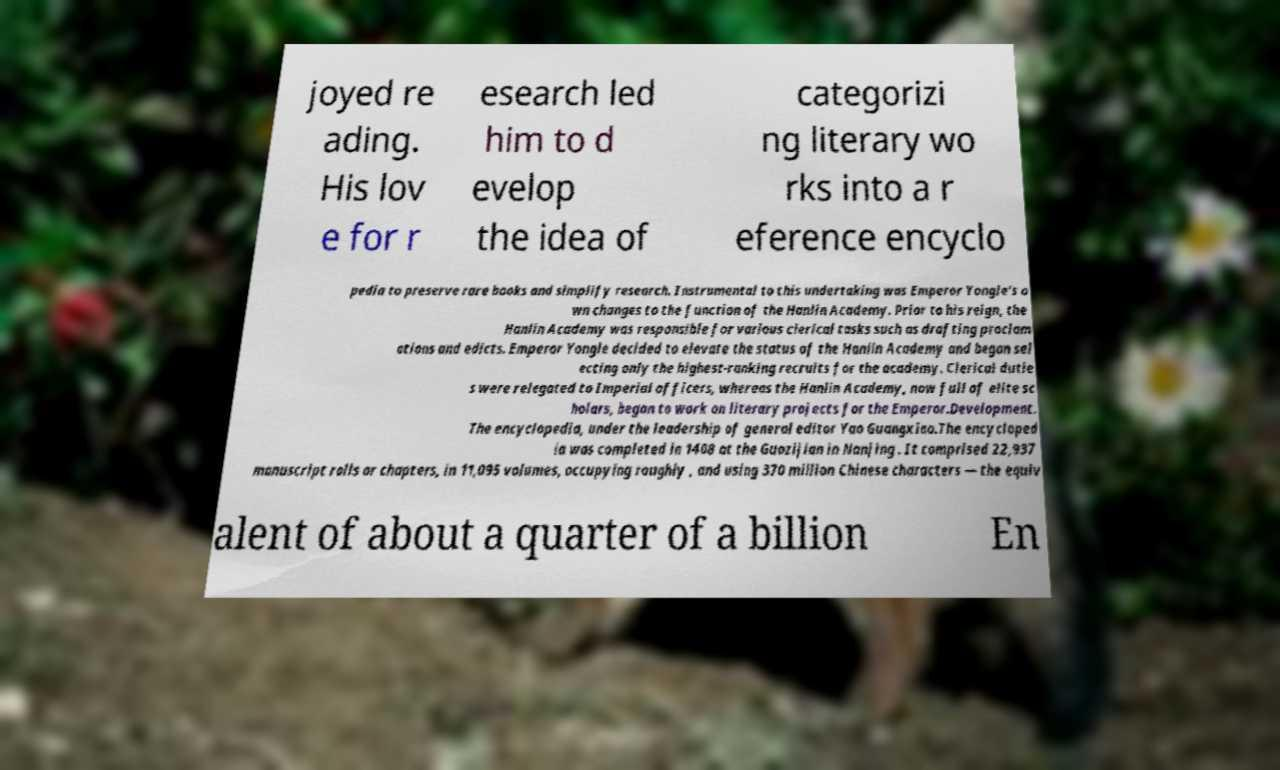Could you assist in decoding the text presented in this image and type it out clearly? joyed re ading. His lov e for r esearch led him to d evelop the idea of categorizi ng literary wo rks into a r eference encyclo pedia to preserve rare books and simplify research. Instrumental to this undertaking was Emperor Yongle’s o wn changes to the function of the Hanlin Academy. Prior to his reign, the Hanlin Academy was responsible for various clerical tasks such as drafting proclam ations and edicts. Emperor Yongle decided to elevate the status of the Hanlin Academy and began sel ecting only the highest-ranking recruits for the academy. Clerical dutie s were relegated to Imperial officers, whereas the Hanlin Academy, now full of elite sc holars, began to work on literary projects for the Emperor.Development. The encyclopedia, under the leadership of general editor Yao Guangxiao.The encycloped ia was completed in 1408 at the Guozijian in Nanjing . It comprised 22,937 manuscript rolls or chapters, in 11,095 volumes, occupying roughly , and using 370 million Chinese characters — the equiv alent of about a quarter of a billion En 